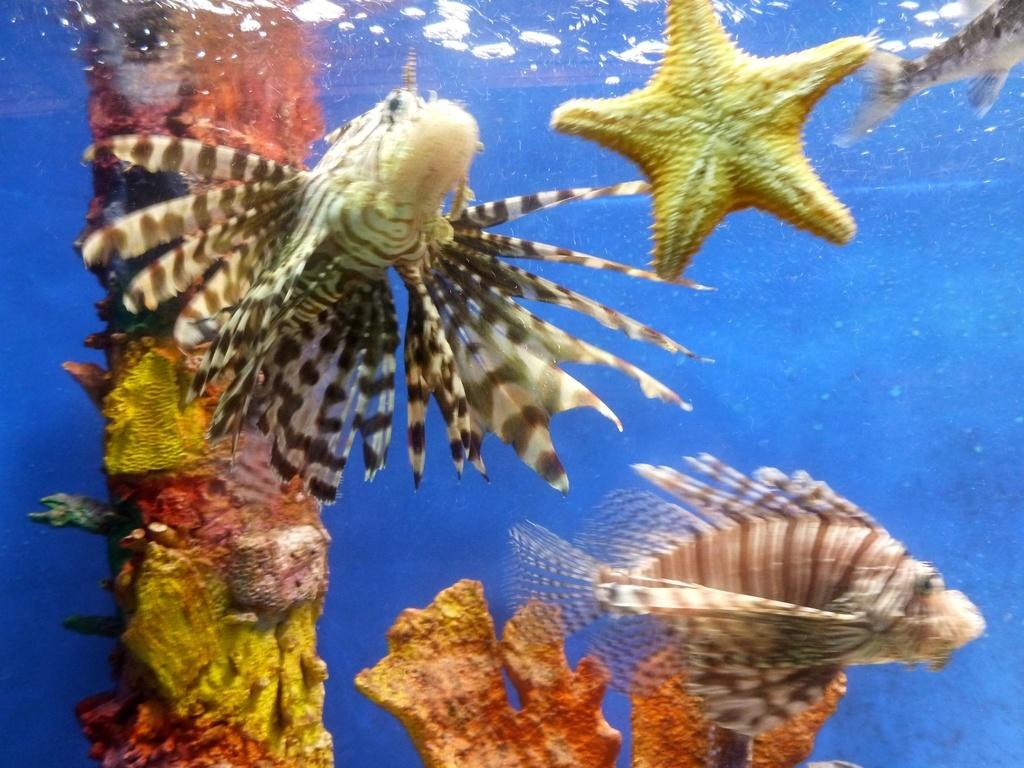What type of marine animals can be seen in the image? There are starfish and fishes in the image. Where are the starfish and fishes located? The starfish and fishes are in the water. What can be seen in the background of the image? There are colorful objects in the background of the image. What color is the background of the image? The background of the image is blue. What type of sweater is the starfish wearing in the image? There are no starfish wearing sweaters in the image, as starfish are marine animals and do not wear clothing. 